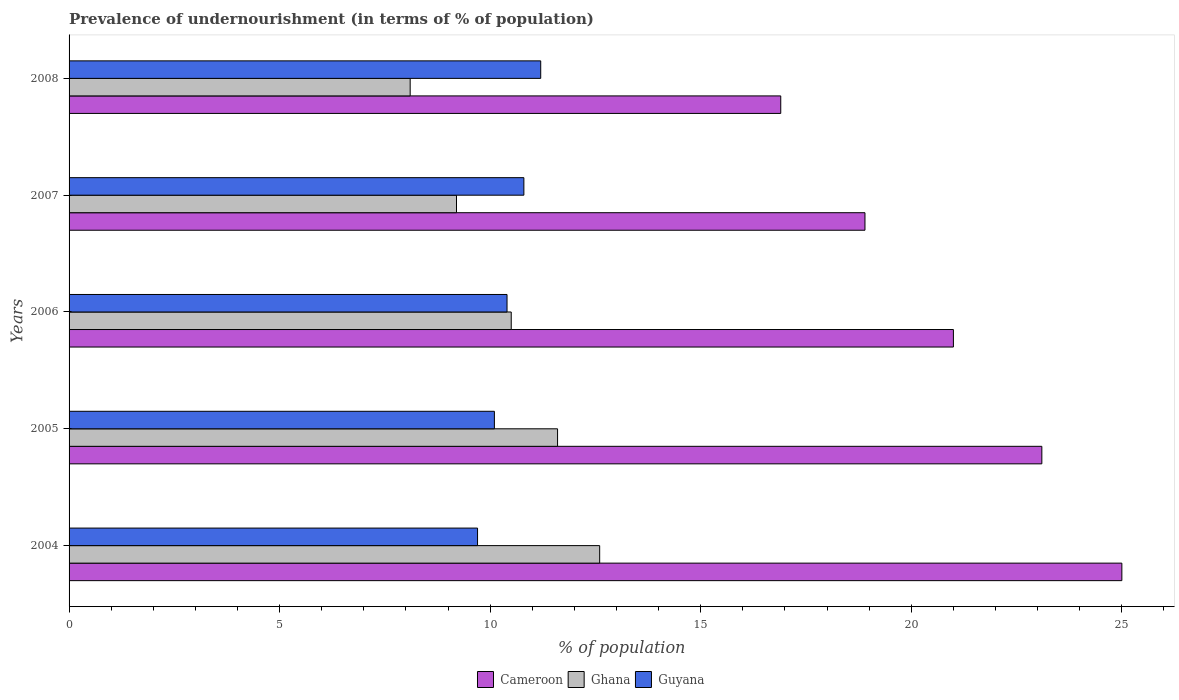Are the number of bars on each tick of the Y-axis equal?
Keep it short and to the point. Yes. How many bars are there on the 2nd tick from the top?
Provide a short and direct response. 3. What is the percentage of undernourished population in Guyana in 2006?
Offer a very short reply. 10.4. Across all years, what is the minimum percentage of undernourished population in Ghana?
Provide a short and direct response. 8.1. What is the total percentage of undernourished population in Cameroon in the graph?
Keep it short and to the point. 104.9. What is the difference between the percentage of undernourished population in Ghana in 2004 and that in 2006?
Keep it short and to the point. 2.1. What is the difference between the percentage of undernourished population in Guyana in 2004 and the percentage of undernourished population in Cameroon in 2006?
Provide a short and direct response. -11.3. What is the average percentage of undernourished population in Ghana per year?
Keep it short and to the point. 10.4. In the year 2006, what is the difference between the percentage of undernourished population in Ghana and percentage of undernourished population in Cameroon?
Your response must be concise. -10.5. In how many years, is the percentage of undernourished population in Cameroon greater than 5 %?
Your answer should be very brief. 5. What is the ratio of the percentage of undernourished population in Ghana in 2005 to that in 2006?
Offer a terse response. 1.1. Is the difference between the percentage of undernourished population in Ghana in 2005 and 2007 greater than the difference between the percentage of undernourished population in Cameroon in 2005 and 2007?
Provide a short and direct response. No. What is the difference between the highest and the second highest percentage of undernourished population in Cameroon?
Provide a short and direct response. 1.9. What is the difference between the highest and the lowest percentage of undernourished population in Cameroon?
Ensure brevity in your answer.  8.1. In how many years, is the percentage of undernourished population in Guyana greater than the average percentage of undernourished population in Guyana taken over all years?
Provide a short and direct response. 2. What does the 1st bar from the top in 2005 represents?
Provide a short and direct response. Guyana. What does the 1st bar from the bottom in 2006 represents?
Keep it short and to the point. Cameroon. How many bars are there?
Offer a terse response. 15. Are all the bars in the graph horizontal?
Your answer should be compact. Yes. How many years are there in the graph?
Your answer should be very brief. 5. Are the values on the major ticks of X-axis written in scientific E-notation?
Ensure brevity in your answer.  No. Does the graph contain any zero values?
Give a very brief answer. No. How many legend labels are there?
Make the answer very short. 3. What is the title of the graph?
Make the answer very short. Prevalence of undernourishment (in terms of % of population). What is the label or title of the X-axis?
Offer a terse response. % of population. What is the % of population in Ghana in 2004?
Ensure brevity in your answer.  12.6. What is the % of population in Guyana in 2004?
Give a very brief answer. 9.7. What is the % of population in Cameroon in 2005?
Provide a succinct answer. 23.1. What is the % of population in Cameroon in 2006?
Keep it short and to the point. 21. What is the % of population of Guyana in 2006?
Your response must be concise. 10.4. What is the % of population of Cameroon in 2007?
Offer a very short reply. 18.9. What is the % of population of Ghana in 2007?
Keep it short and to the point. 9.2. What is the % of population in Guyana in 2007?
Offer a very short reply. 10.8. What is the % of population of Cameroon in 2008?
Provide a succinct answer. 16.9. What is the % of population in Ghana in 2008?
Provide a succinct answer. 8.1. Across all years, what is the maximum % of population in Cameroon?
Give a very brief answer. 25. Across all years, what is the maximum % of population in Guyana?
Make the answer very short. 11.2. Across all years, what is the minimum % of population of Guyana?
Your answer should be very brief. 9.7. What is the total % of population in Cameroon in the graph?
Ensure brevity in your answer.  104.9. What is the total % of population in Guyana in the graph?
Offer a very short reply. 52.2. What is the difference between the % of population of Cameroon in 2004 and that in 2005?
Offer a terse response. 1.9. What is the difference between the % of population of Ghana in 2004 and that in 2005?
Your answer should be compact. 1. What is the difference between the % of population of Cameroon in 2004 and that in 2007?
Offer a very short reply. 6.1. What is the difference between the % of population in Cameroon in 2004 and that in 2008?
Provide a succinct answer. 8.1. What is the difference between the % of population of Guyana in 2004 and that in 2008?
Offer a very short reply. -1.5. What is the difference between the % of population of Cameroon in 2005 and that in 2007?
Your answer should be compact. 4.2. What is the difference between the % of population in Ghana in 2005 and that in 2007?
Offer a very short reply. 2.4. What is the difference between the % of population of Cameroon in 2005 and that in 2008?
Provide a short and direct response. 6.2. What is the difference between the % of population in Ghana in 2005 and that in 2008?
Provide a succinct answer. 3.5. What is the difference between the % of population in Guyana in 2006 and that in 2007?
Provide a succinct answer. -0.4. What is the difference between the % of population in Cameroon in 2006 and that in 2008?
Ensure brevity in your answer.  4.1. What is the difference between the % of population in Ghana in 2006 and that in 2008?
Give a very brief answer. 2.4. What is the difference between the % of population of Guyana in 2006 and that in 2008?
Offer a terse response. -0.8. What is the difference between the % of population of Ghana in 2007 and that in 2008?
Offer a very short reply. 1.1. What is the difference between the % of population in Cameroon in 2004 and the % of population in Ghana in 2005?
Provide a short and direct response. 13.4. What is the difference between the % of population in Cameroon in 2004 and the % of population in Guyana in 2005?
Give a very brief answer. 14.9. What is the difference between the % of population of Cameroon in 2004 and the % of population of Guyana in 2006?
Your answer should be compact. 14.6. What is the difference between the % of population in Cameroon in 2004 and the % of population in Guyana in 2007?
Offer a terse response. 14.2. What is the difference between the % of population in Cameroon in 2004 and the % of population in Ghana in 2008?
Your answer should be very brief. 16.9. What is the difference between the % of population in Ghana in 2004 and the % of population in Guyana in 2008?
Provide a short and direct response. 1.4. What is the difference between the % of population in Cameroon in 2005 and the % of population in Guyana in 2007?
Your answer should be very brief. 12.3. What is the difference between the % of population of Cameroon in 2005 and the % of population of Ghana in 2008?
Your response must be concise. 15. What is the difference between the % of population of Cameroon in 2005 and the % of population of Guyana in 2008?
Offer a very short reply. 11.9. What is the difference between the % of population in Cameroon in 2006 and the % of population in Guyana in 2008?
Ensure brevity in your answer.  9.8. What is the difference between the % of population of Cameroon in 2007 and the % of population of Ghana in 2008?
Make the answer very short. 10.8. What is the difference between the % of population in Cameroon in 2007 and the % of population in Guyana in 2008?
Offer a terse response. 7.7. What is the average % of population of Cameroon per year?
Give a very brief answer. 20.98. What is the average % of population in Ghana per year?
Your answer should be compact. 10.4. What is the average % of population of Guyana per year?
Make the answer very short. 10.44. In the year 2005, what is the difference between the % of population of Cameroon and % of population of Guyana?
Your response must be concise. 13. In the year 2005, what is the difference between the % of population in Ghana and % of population in Guyana?
Your answer should be compact. 1.5. In the year 2006, what is the difference between the % of population of Cameroon and % of population of Ghana?
Make the answer very short. 10.5. What is the ratio of the % of population of Cameroon in 2004 to that in 2005?
Offer a terse response. 1.08. What is the ratio of the % of population in Ghana in 2004 to that in 2005?
Give a very brief answer. 1.09. What is the ratio of the % of population in Guyana in 2004 to that in 2005?
Offer a terse response. 0.96. What is the ratio of the % of population in Cameroon in 2004 to that in 2006?
Keep it short and to the point. 1.19. What is the ratio of the % of population of Guyana in 2004 to that in 2006?
Provide a short and direct response. 0.93. What is the ratio of the % of population of Cameroon in 2004 to that in 2007?
Provide a short and direct response. 1.32. What is the ratio of the % of population of Ghana in 2004 to that in 2007?
Your answer should be very brief. 1.37. What is the ratio of the % of population of Guyana in 2004 to that in 2007?
Your answer should be very brief. 0.9. What is the ratio of the % of population of Cameroon in 2004 to that in 2008?
Provide a short and direct response. 1.48. What is the ratio of the % of population of Ghana in 2004 to that in 2008?
Offer a very short reply. 1.56. What is the ratio of the % of population of Guyana in 2004 to that in 2008?
Provide a short and direct response. 0.87. What is the ratio of the % of population of Cameroon in 2005 to that in 2006?
Your answer should be compact. 1.1. What is the ratio of the % of population in Ghana in 2005 to that in 2006?
Your answer should be compact. 1.1. What is the ratio of the % of population of Guyana in 2005 to that in 2006?
Ensure brevity in your answer.  0.97. What is the ratio of the % of population of Cameroon in 2005 to that in 2007?
Ensure brevity in your answer.  1.22. What is the ratio of the % of population in Ghana in 2005 to that in 2007?
Offer a very short reply. 1.26. What is the ratio of the % of population in Guyana in 2005 to that in 2007?
Your response must be concise. 0.94. What is the ratio of the % of population of Cameroon in 2005 to that in 2008?
Provide a succinct answer. 1.37. What is the ratio of the % of population of Ghana in 2005 to that in 2008?
Make the answer very short. 1.43. What is the ratio of the % of population of Guyana in 2005 to that in 2008?
Offer a very short reply. 0.9. What is the ratio of the % of population in Cameroon in 2006 to that in 2007?
Keep it short and to the point. 1.11. What is the ratio of the % of population in Ghana in 2006 to that in 2007?
Provide a short and direct response. 1.14. What is the ratio of the % of population of Cameroon in 2006 to that in 2008?
Provide a succinct answer. 1.24. What is the ratio of the % of population of Ghana in 2006 to that in 2008?
Your answer should be compact. 1.3. What is the ratio of the % of population of Cameroon in 2007 to that in 2008?
Offer a very short reply. 1.12. What is the ratio of the % of population of Ghana in 2007 to that in 2008?
Provide a short and direct response. 1.14. What is the ratio of the % of population of Guyana in 2007 to that in 2008?
Your answer should be compact. 0.96. What is the difference between the highest and the second highest % of population in Ghana?
Offer a terse response. 1. What is the difference between the highest and the lowest % of population in Guyana?
Your answer should be compact. 1.5. 